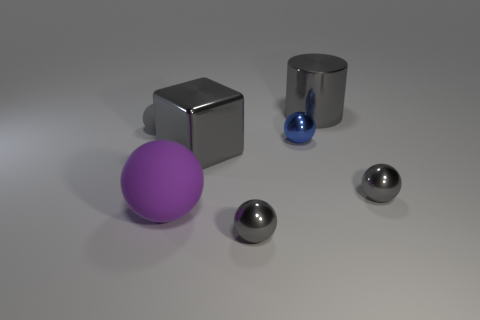Subtract all small blue spheres. How many spheres are left? 4 Subtract all purple blocks. How many gray balls are left? 3 Add 2 big green rubber cylinders. How many objects exist? 9 Subtract all blue balls. How many balls are left? 4 Subtract all spheres. How many objects are left? 2 Subtract all cyan spheres. Subtract all purple cylinders. How many spheres are left? 5 Subtract 0 brown cylinders. How many objects are left? 7 Subtract all tiny gray rubber things. Subtract all cylinders. How many objects are left? 5 Add 2 tiny gray metallic spheres. How many tiny gray metallic spheres are left? 4 Add 3 balls. How many balls exist? 8 